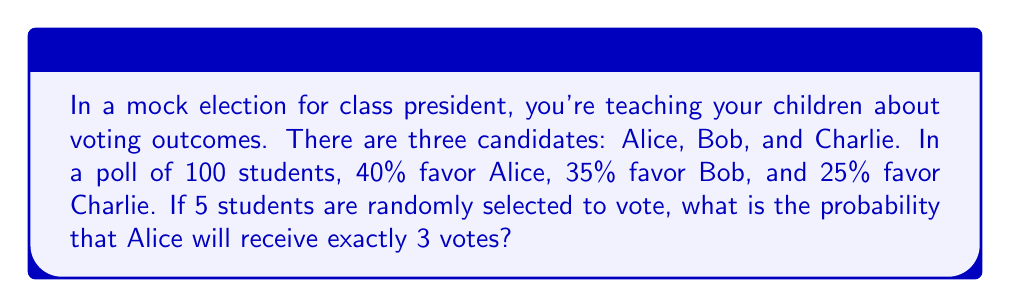Could you help me with this problem? To solve this problem, we'll use the binomial probability formula:

$$P(X = k) = \binom{n}{k} p^k (1-p)^{n-k}$$

Where:
$n$ = number of trials (students voting)
$k$ = number of successes (votes for Alice)
$p$ = probability of success on each trial (probability of voting for Alice)

Given:
$n = 5$ (5 students voting)
$k = 3$ (we want exactly 3 votes for Alice)
$p = 0.40$ (40% of students favor Alice)

Step 1: Calculate the binomial coefficient $\binom{5}{3}$
$$\binom{5}{3} = \frac{5!}{3!(5-3)!} = \frac{5 \cdot 4}{2 \cdot 1} = 10$$

Step 2: Calculate $p^k$
$$0.40^3 = 0.064$$

Step 3: Calculate $(1-p)^{n-k}$
$$(1-0.40)^{5-3} = 0.60^2 = 0.36$$

Step 4: Multiply all parts together
$$10 \cdot 0.064 \cdot 0.36 = 0.2304$$

Therefore, the probability of Alice receiving exactly 3 votes out of 5 random voters is 0.2304 or about 23.04%.
Answer: The probability that Alice will receive exactly 3 votes out of 5 randomly selected students is 0.2304 or approximately 23.04%. 